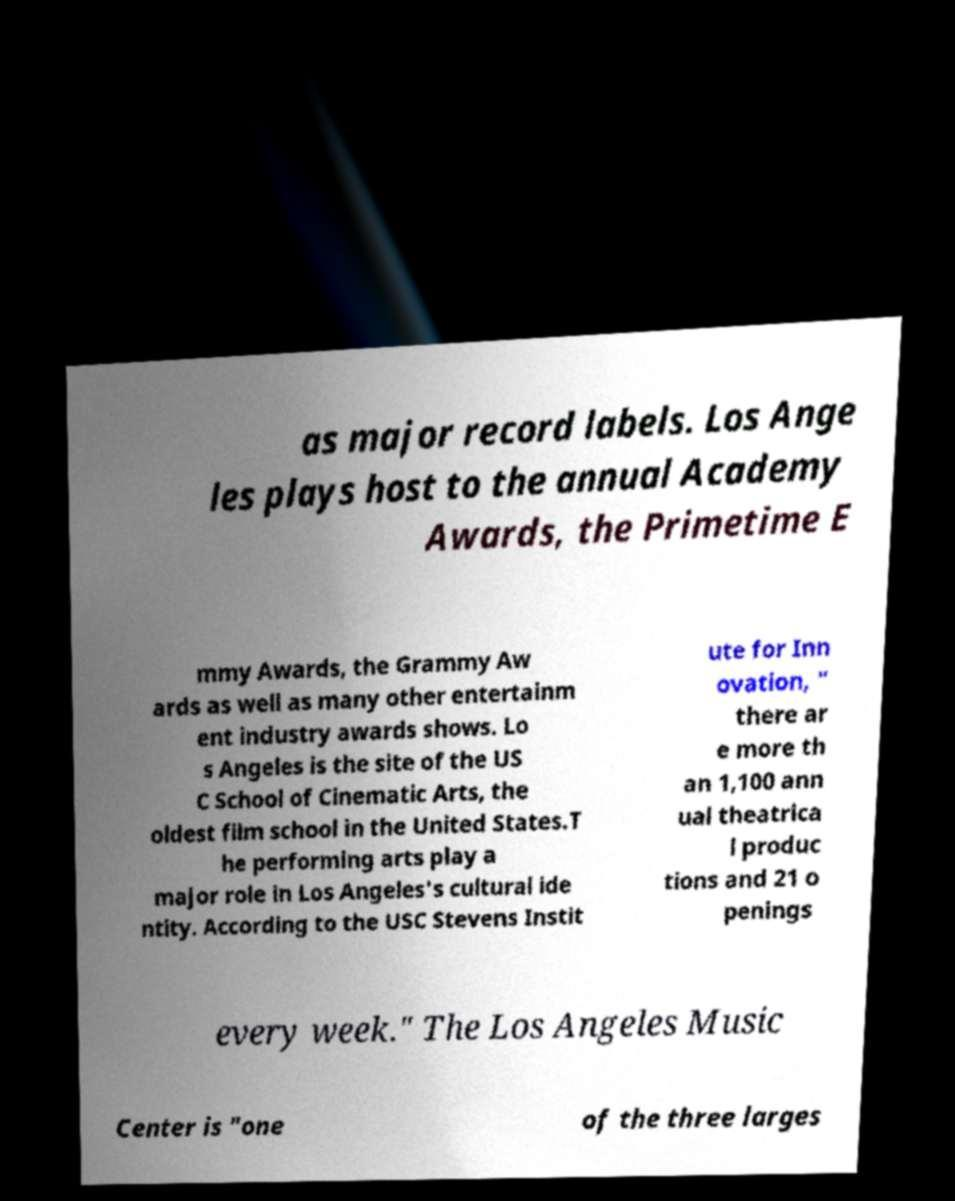Can you read and provide the text displayed in the image?This photo seems to have some interesting text. Can you extract and type it out for me? as major record labels. Los Ange les plays host to the annual Academy Awards, the Primetime E mmy Awards, the Grammy Aw ards as well as many other entertainm ent industry awards shows. Lo s Angeles is the site of the US C School of Cinematic Arts, the oldest film school in the United States.T he performing arts play a major role in Los Angeles's cultural ide ntity. According to the USC Stevens Instit ute for Inn ovation, " there ar e more th an 1,100 ann ual theatrica l produc tions and 21 o penings every week." The Los Angeles Music Center is "one of the three larges 